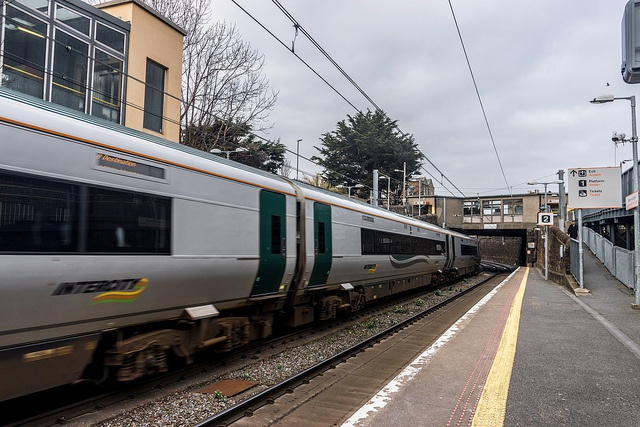Describe the objects in this image and their specific colors. I can see train in gray, black, darkgray, and lightgray tones and bird in gray, lavender, darkgray, and lightgray tones in this image. 